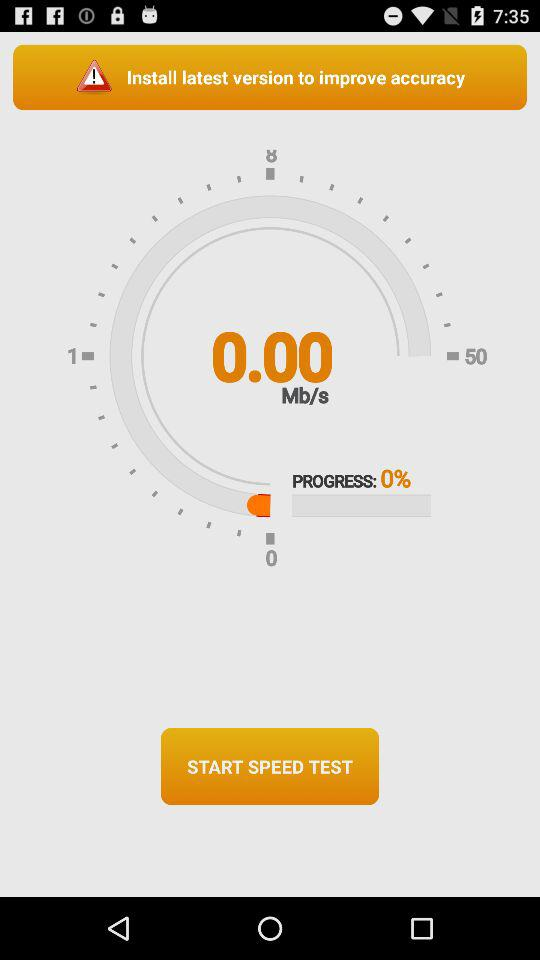What is the percentage of the download that has been completed?
Answer the question using a single word or phrase. 0% 